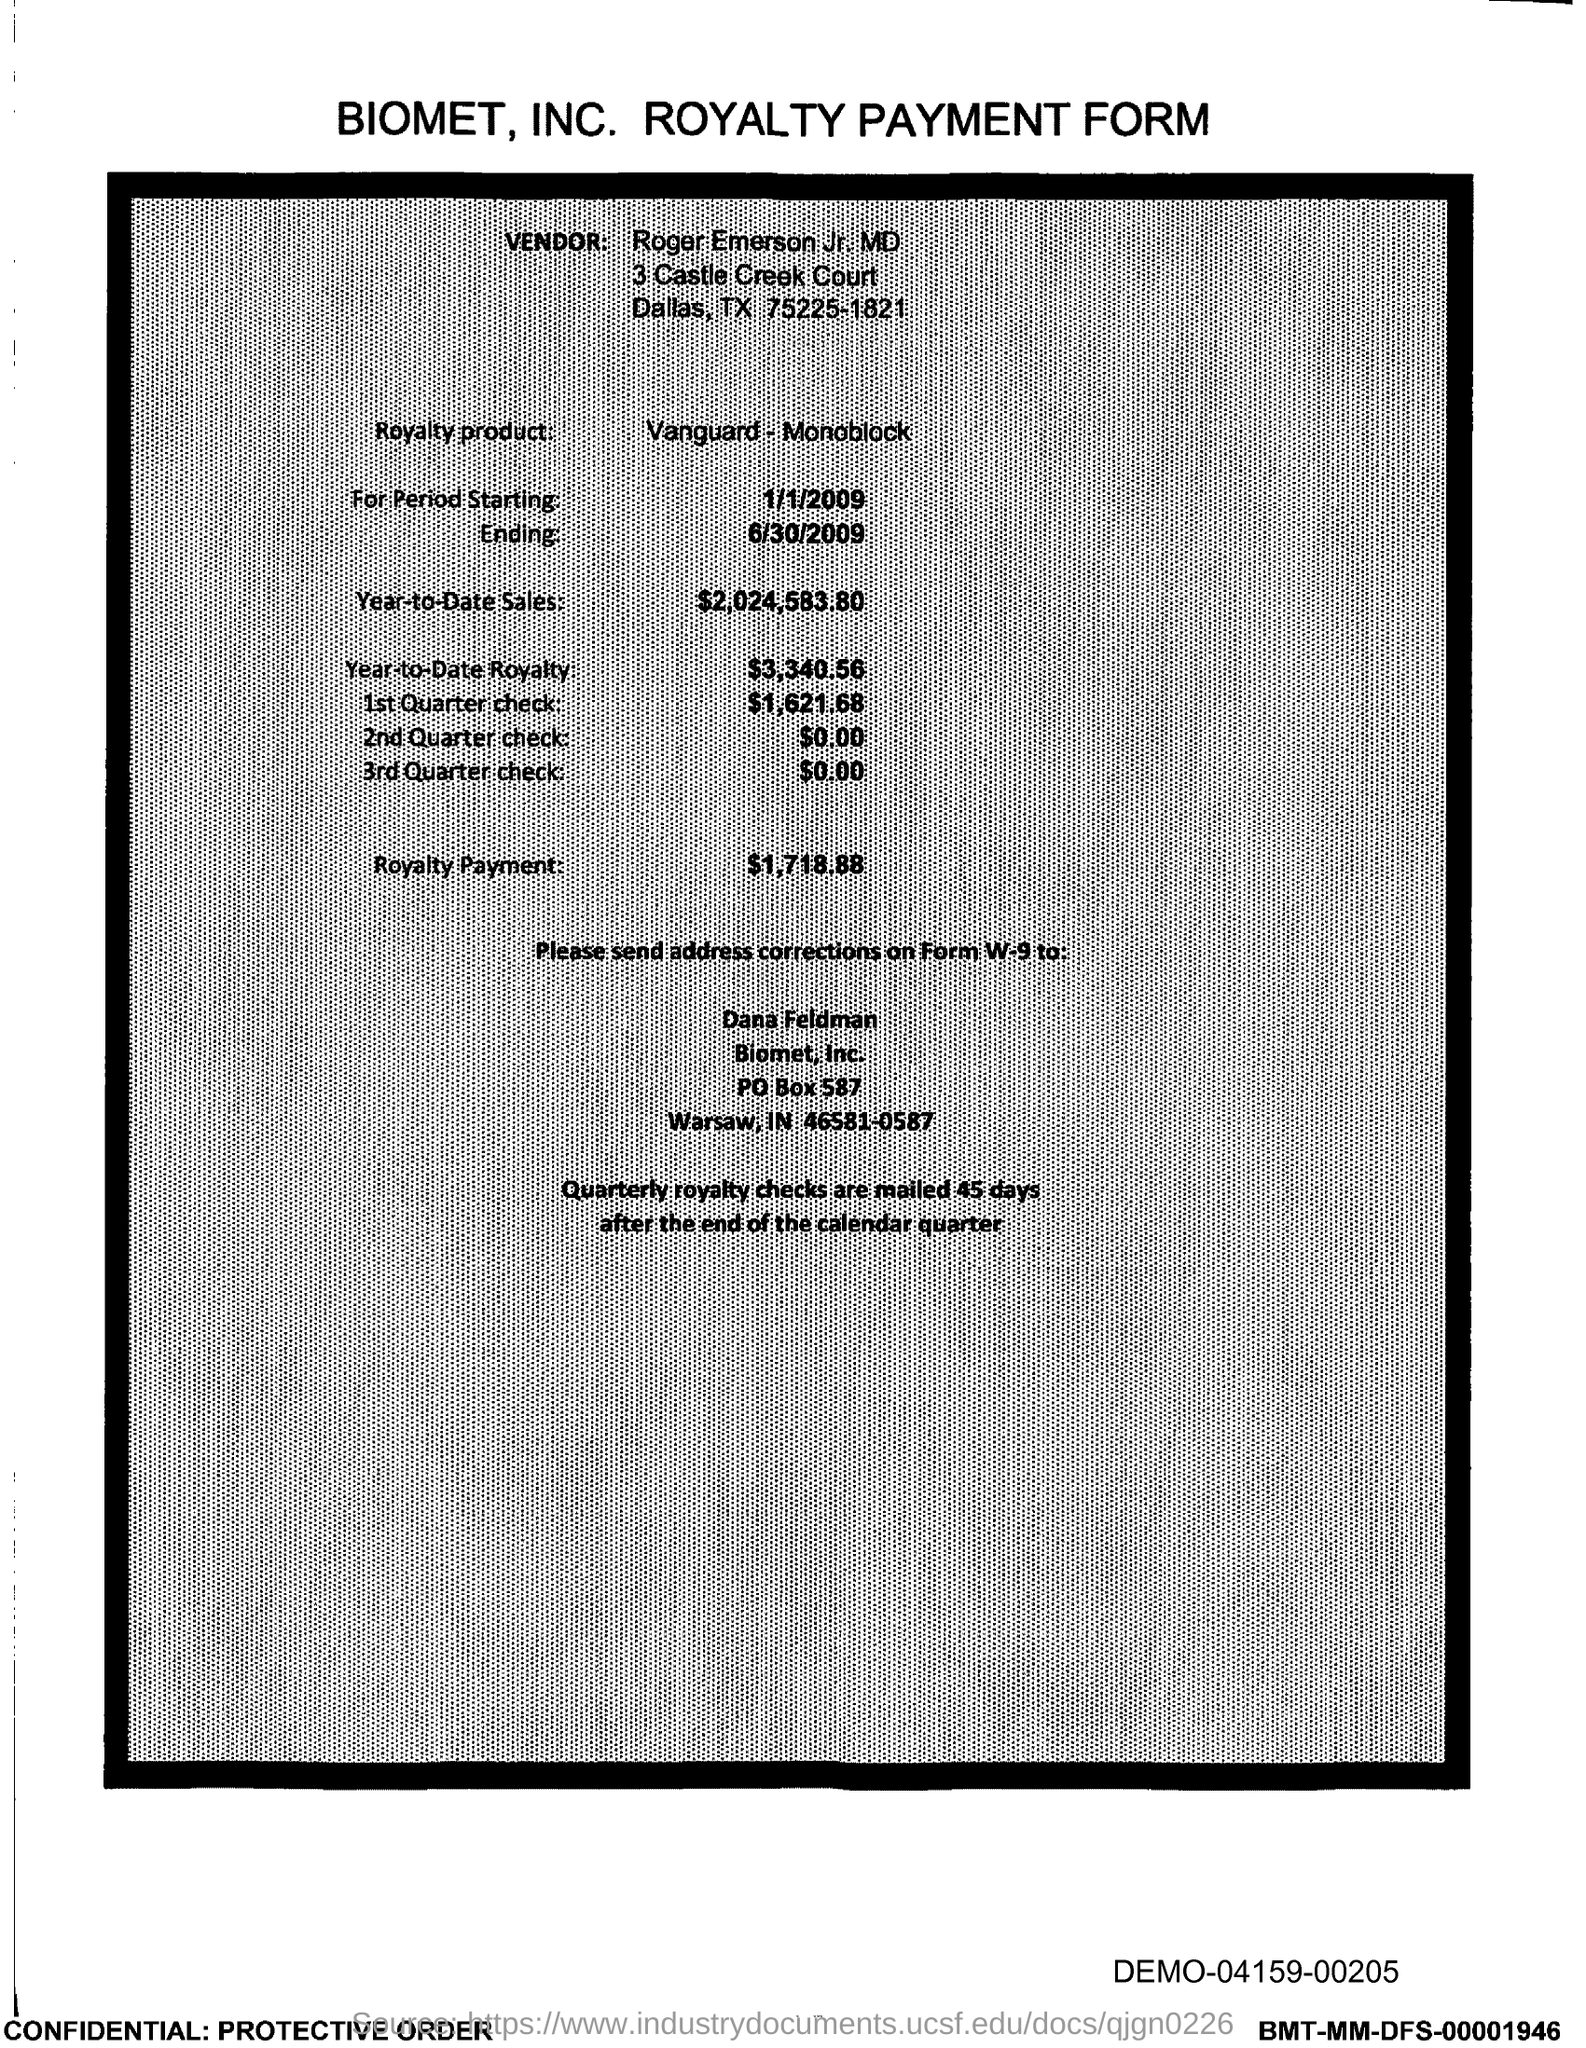Identify some key points in this picture. The royalty product is given in the form of Vanguard-Monoblock. The royalty payment amount of the product is $1,718.88. The amount of the first quarter check mentioned in the form is $1,621.68. The royalty payment form belongs to Biomet, Inc. The quartely royalty checks are mailed 45 days after the end of the calendar quarter. 